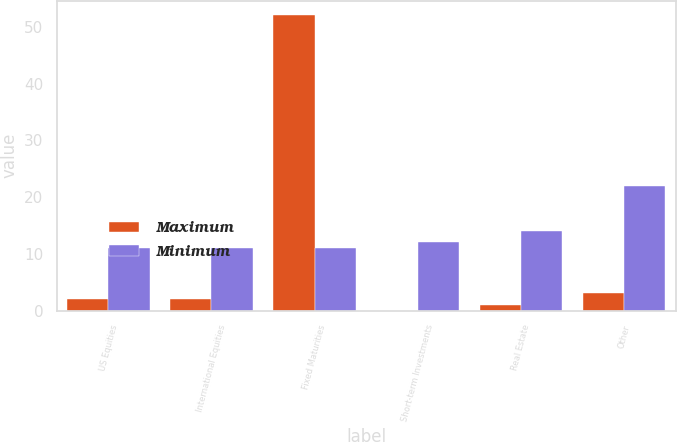Convert chart to OTSL. <chart><loc_0><loc_0><loc_500><loc_500><stacked_bar_chart><ecel><fcel>US Equities<fcel>International Equities<fcel>Fixed Maturities<fcel>Short-term Investments<fcel>Real Estate<fcel>Other<nl><fcel>Maximum<fcel>2<fcel>2<fcel>52<fcel>0<fcel>1<fcel>3<nl><fcel>Minimum<fcel>11<fcel>11<fcel>11<fcel>12<fcel>14<fcel>22<nl></chart> 